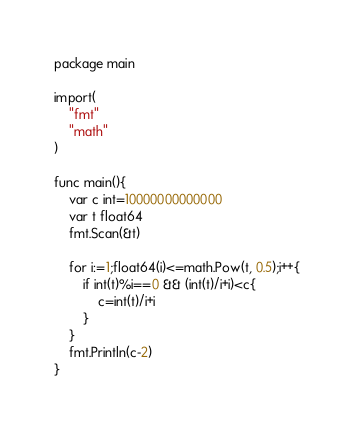Convert code to text. <code><loc_0><loc_0><loc_500><loc_500><_Go_>package main

import(
	"fmt"
	"math"
)

func main(){
	var c int=10000000000000
	var t float64
	fmt.Scan(&t)

	for i:=1;float64(i)<=math.Pow(t, 0.5);i++{
		if int(t)%i==0 && (int(t)/i+i)<c{
			c=int(t)/i+i
		}
	}
	fmt.Println(c-2)
}</code> 